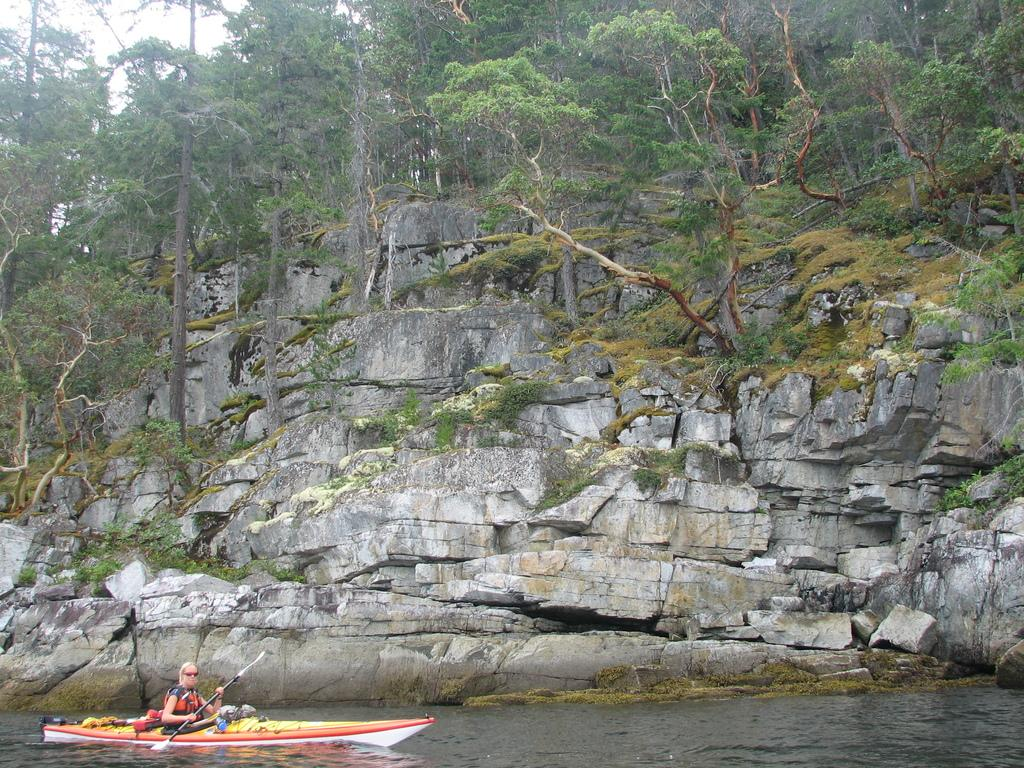What is the person in the image doing? There is a person sailing a boat in the image. What natural features can be seen in the image? Rocks, trees, plants, and grass are visible in the image. What part of the natural environment is not visible in the image? The image does not show any water, as the person is sailing a boat. What is visible in the sky in the image? The sky is visible in the image. Can you see any suggestions being made in the image? There is no suggestion present in the image; it features a person sailing a boat and various natural features. Is there a fight happening in the image? There is no fight present in the image; it features a person sailing a boat and various natural features. 